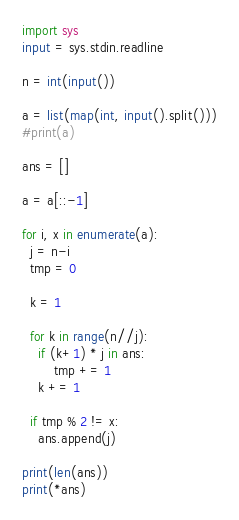<code> <loc_0><loc_0><loc_500><loc_500><_Python_>import sys
input = sys.stdin.readline

n = int(input())

a = list(map(int, input().split()))
#print(a)

ans = []

a = a[::-1]

for i, x in enumerate(a):
  j = n-i
  tmp = 0
  
  k = 1
  
  for k in range(n//j):
    if (k+1) * j in ans:
	    tmp += 1
    k += 1
    
  if tmp % 2 != x:
    ans.append(j)

print(len(ans))
print(*ans)</code> 